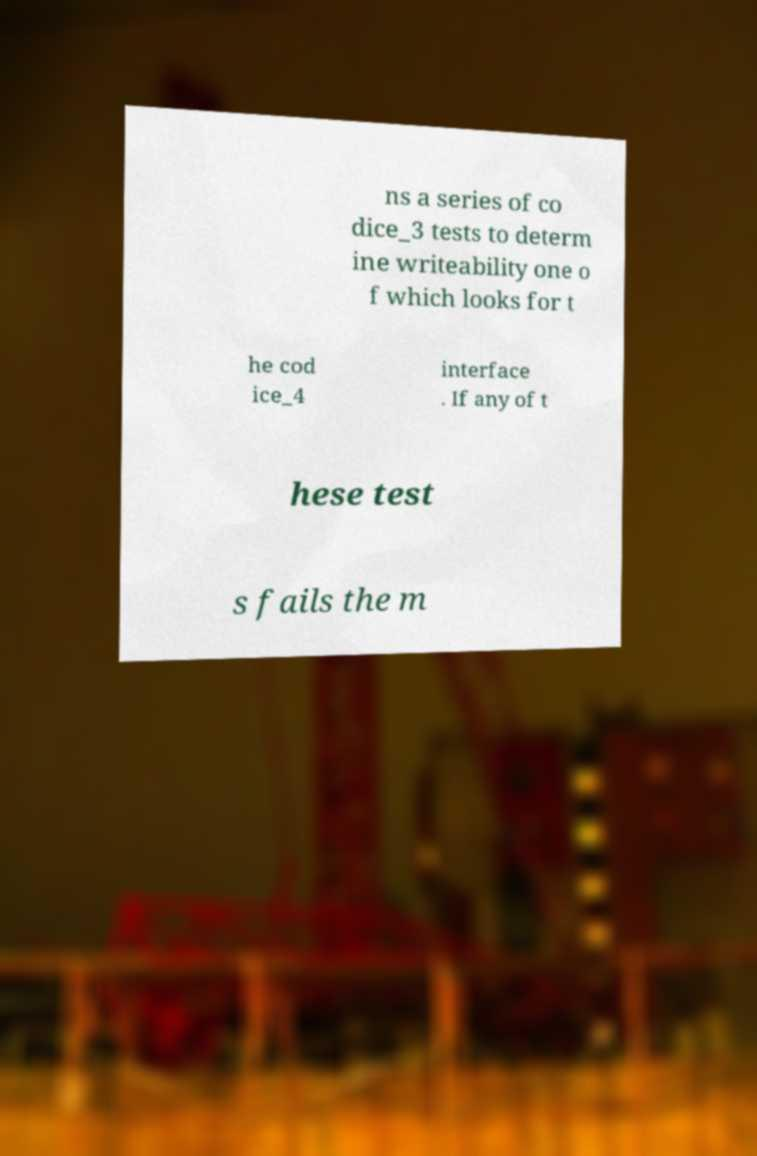Can you accurately transcribe the text from the provided image for me? ns a series of co dice_3 tests to determ ine writeability one o f which looks for t he cod ice_4 interface . If any of t hese test s fails the m 